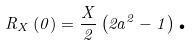Convert formula to latex. <formula><loc_0><loc_0><loc_500><loc_500>R _ { X } \left ( 0 \right ) = \frac { X } { 2 } \left ( 2 a ^ { 2 } - 1 \right ) \text {.}</formula> 